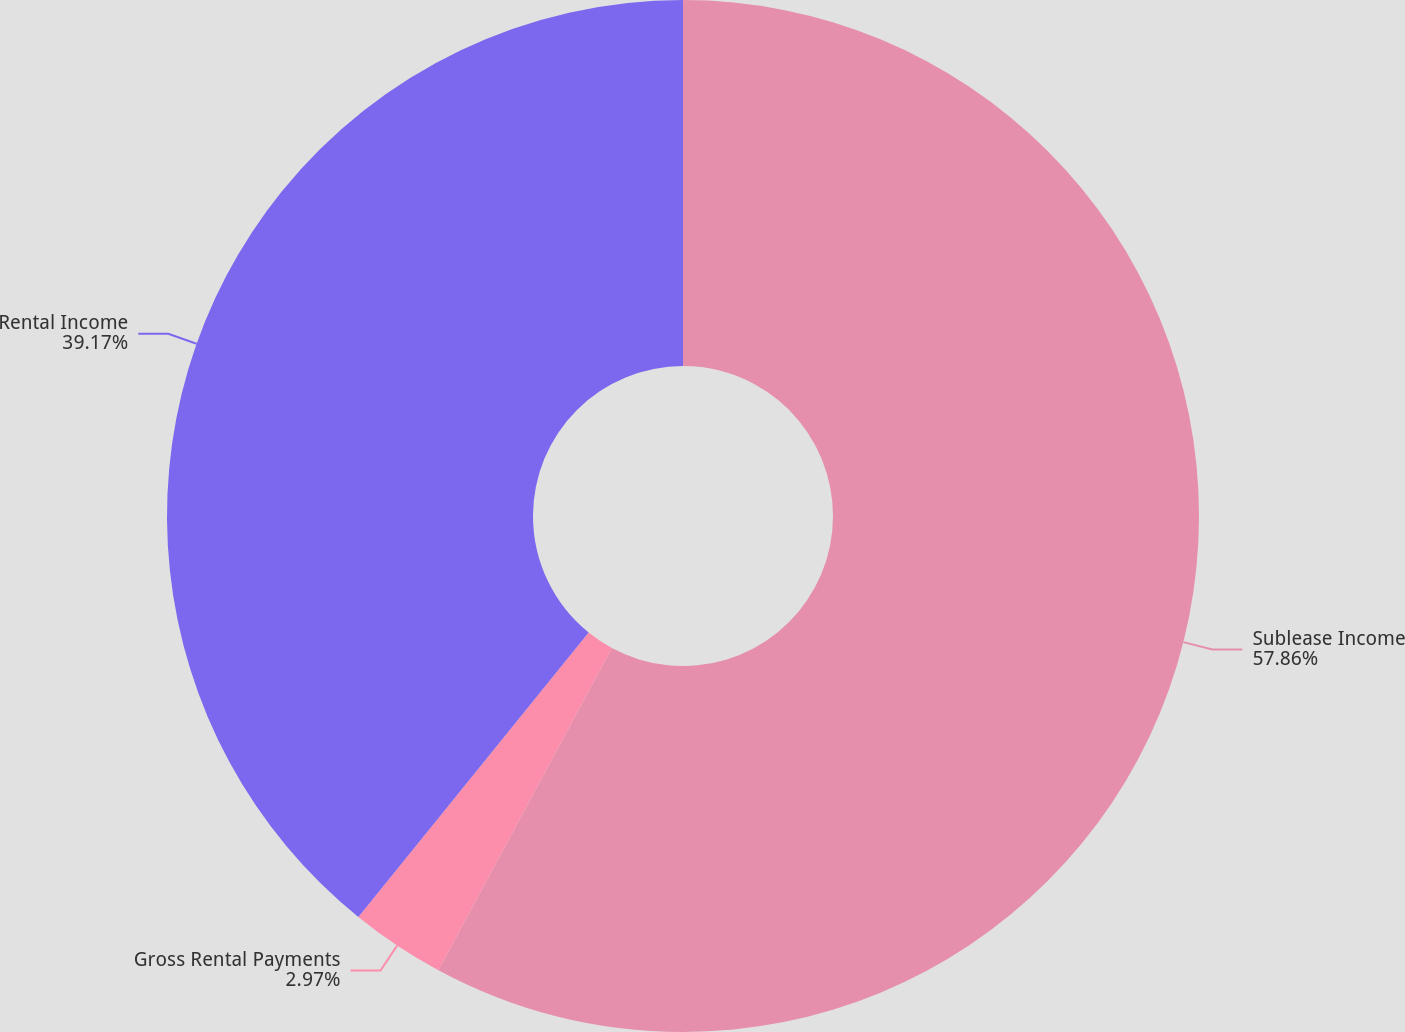Convert chart. <chart><loc_0><loc_0><loc_500><loc_500><pie_chart><fcel>Sublease Income<fcel>Gross Rental Payments<fcel>Rental Income<nl><fcel>57.86%<fcel>2.97%<fcel>39.17%<nl></chart> 